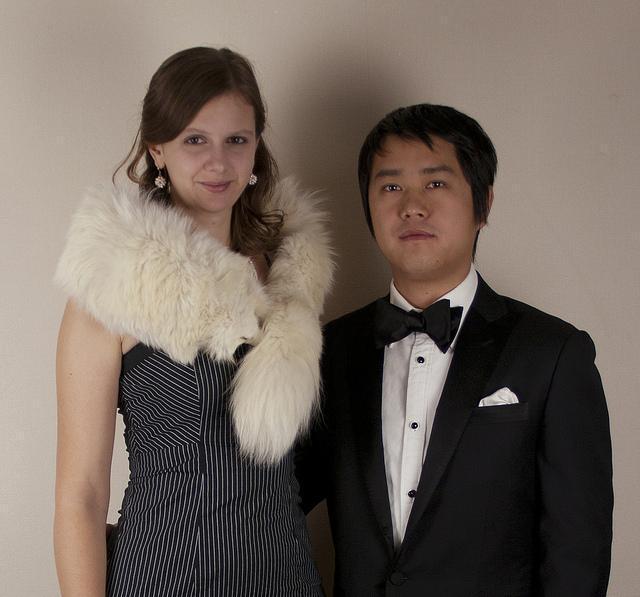How many people are visible?
Give a very brief answer. 2. 